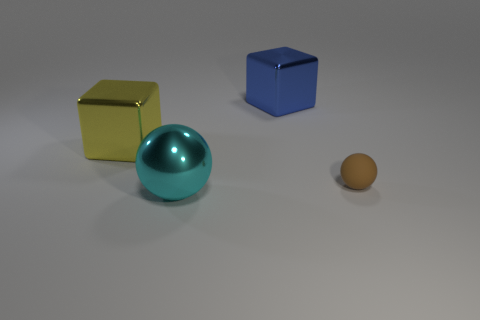Add 1 big blue shiny things. How many objects exist? 5 Add 1 big blocks. How many big blocks are left? 3 Add 2 blue metal things. How many blue metal things exist? 3 Subtract 0 gray cubes. How many objects are left? 4 Subtract all metallic blocks. Subtract all cyan metal spheres. How many objects are left? 1 